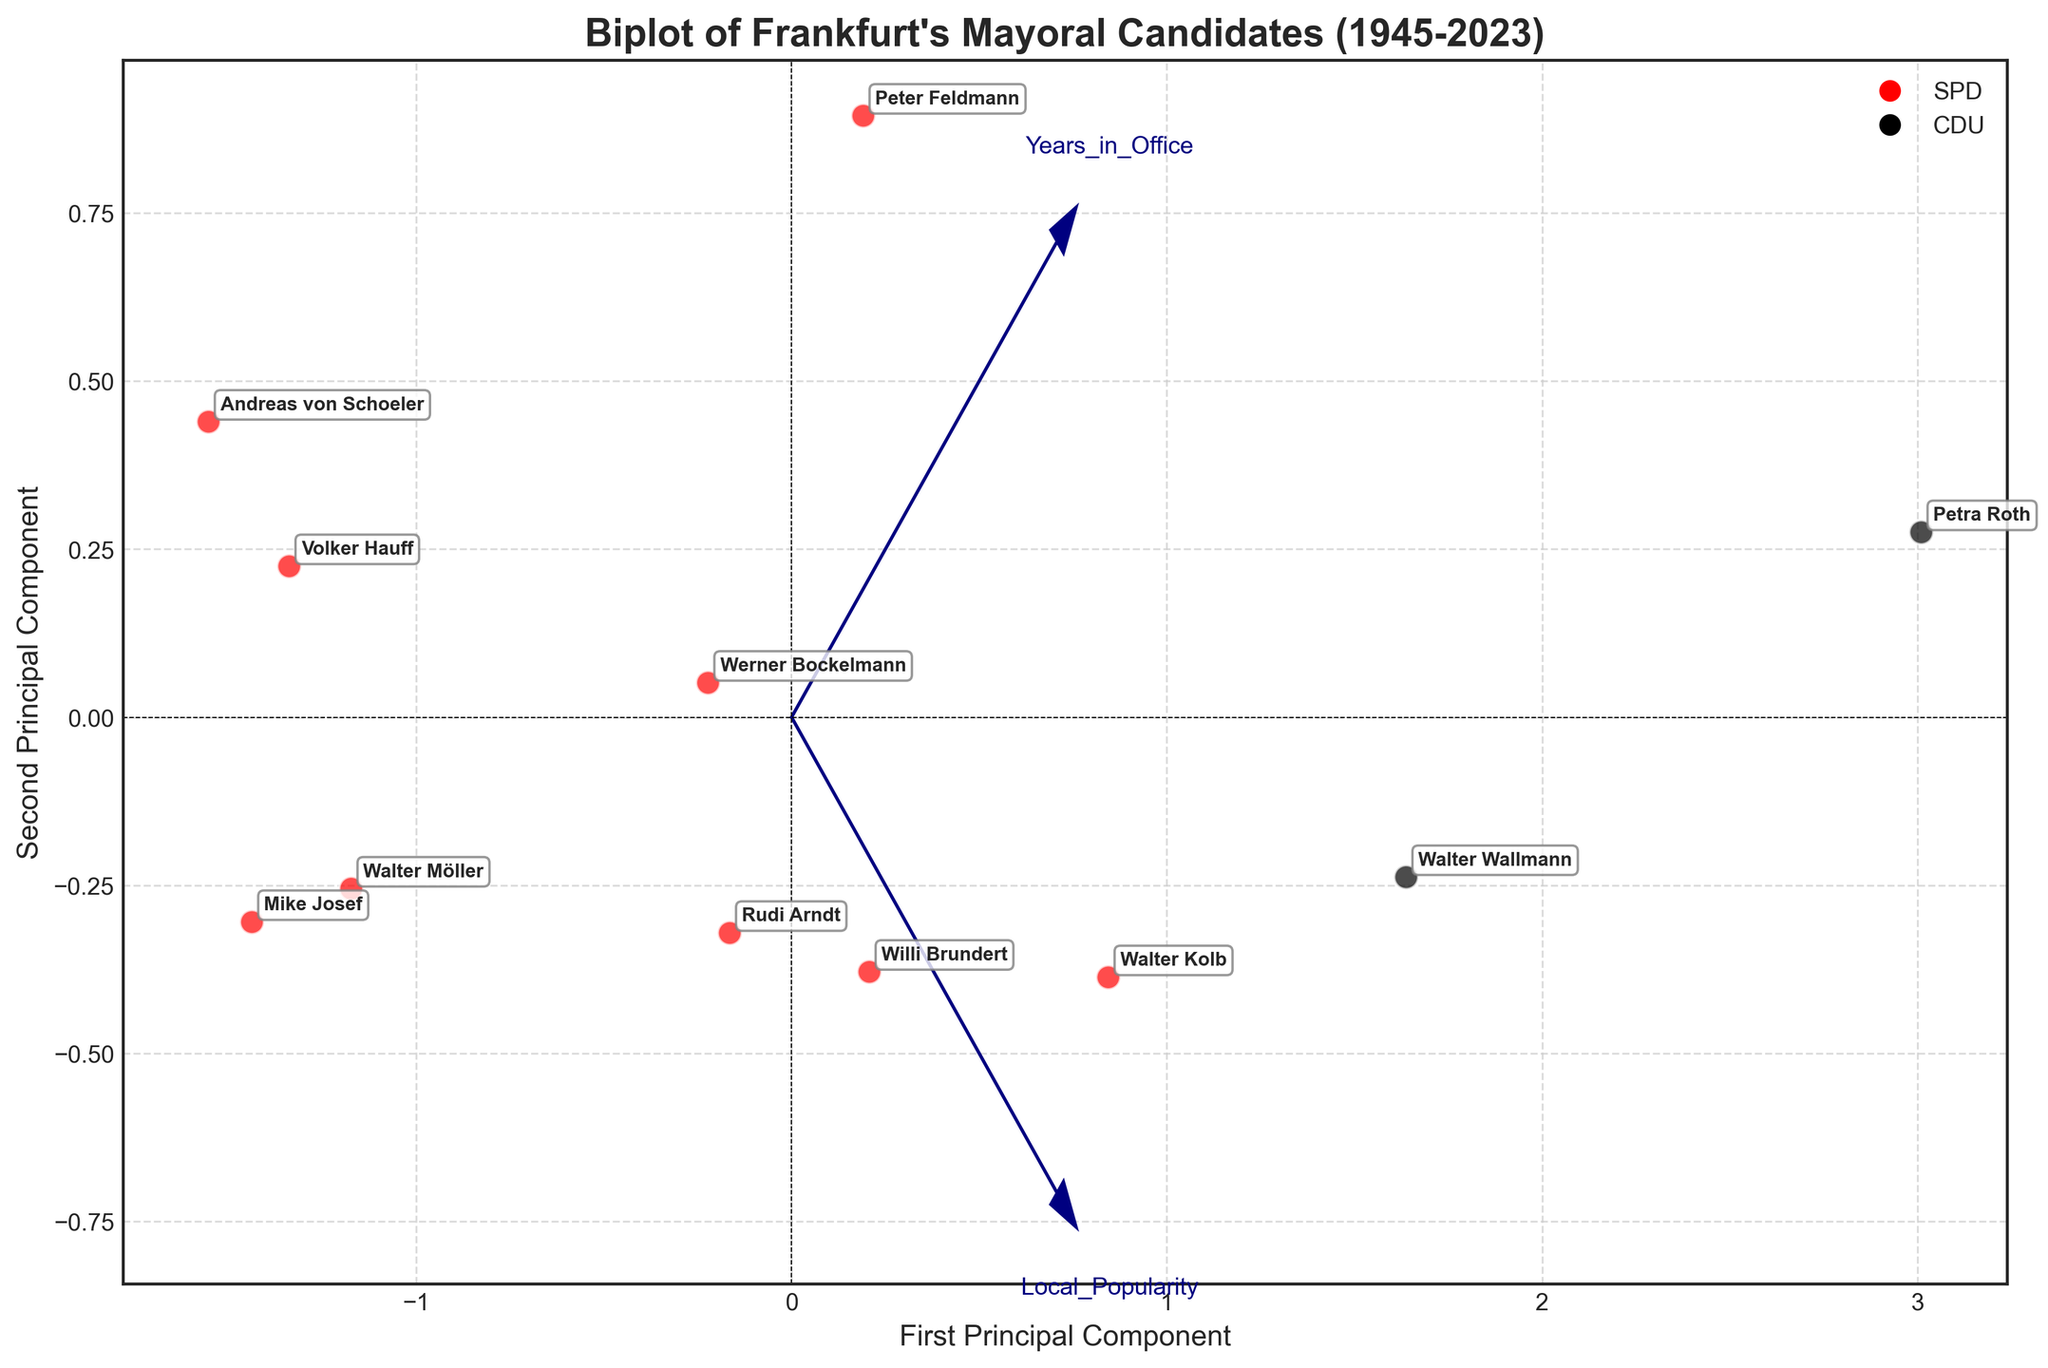What are the main components represented on the axes of the biplot? The x-axis represents the first principal component and the y-axis represents the second principal component of the PCA.
Answer: First Principal Component, Second Principal Component How can you identify the candidates from the CDU party? CDU candidates are marked with black color (labels and points).
Answer: Black color Which candidate has been in office for the shortest period? The candidate near the origin, which represents the shortest vector in the direction of "Years in Office", is Mike Josef.
Answer: Mike Josef Which candidate has the highest local popularity? The candidate farthest along the "Local Popularity" vector is Petra Roth.
Answer: Petra Roth Compare the tenure and popularity of Walter Wallmann and Walter Möller. Which one had a longer tenure? Walter Wallmann has a longer tenure, as he is further along the "Years in Office" vector compared to Walter Möller, who is closer to the origin.
Answer: Walter Wallmann Between Peter Feldmann and Rudi Arndt, who has higher local popularity? Peter Feldmann and Rudi Arndt can be compared based on their position along the "Local Popularity" vector. Peter Feldmann is slightly closer to the "Local Popularity" vector end.
Answer: Peter Feldmann Who are the mayors that focused on economic growth and reconstruction, and which party were they affiliated with? Werner Bockelmann focused on Economic Growth and Walter Kolb focused on Reconstruction, both from SPD (red color).
Answer: Werner Bockelmann, Walter Kolb (SPD) Are there any candidates whose local popularity is above 0.75? The candidates above 0.75 local popularity are Walter Wallmann and Petra Roth, as they are farthest along the "Local Popularity" vector.
Answer: Walter Wallmann, Petra Roth Identify the candidate with terms in office exceeding 10 years. Who is it and what was their campaign focus? Petra Roth and Walter Wallmann, with campaign focuses on International Relations and Environmental Policy respectively, as they are along the longest vectors in "Years in Office".
Answer: Petra Roth - International Relations, Walter Wallmann - Environmental Policy Which candidate from the SPD party has a focus on digital innovation? Mike Josef from the SPD party focused on Digital Innovation, marked in red and aligned with the relevant campaign focus.
Answer: Mike Josef 